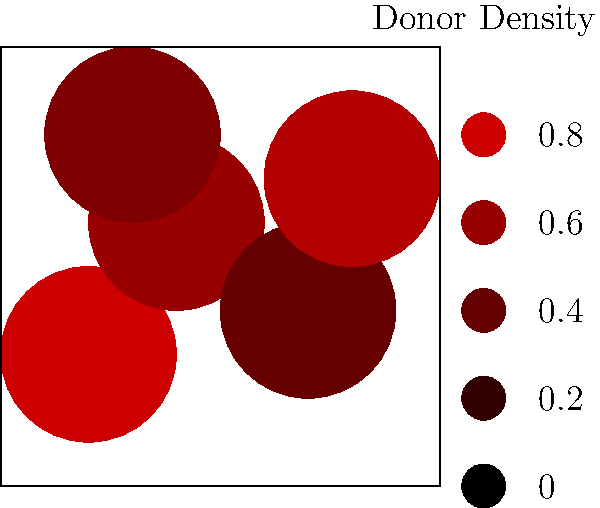Based on the heat map shown, which region of the map appears to have the highest concentration of donors, and what strategy might be most effective for engaging donors in this area? To answer this question, we need to analyze the heat map and consider fundraising strategies:

1. Analyze the heat map:
   - The map shows donor density across different regions.
   - Darker red areas indicate higher donor concentrations.
   - The darkest red area is in the upper right quadrant of the map.

2. Identify the highest concentration:
   - The upper right quadrant (northeast region) has the darkest red color.
   - This indicates the highest donor density in this area.

3. Consider effective engagement strategies:
   - For high-density donor areas, personalized approaches are often effective.
   - Hosting local events can capitalize on the concentration of donors.
   - Peer-to-peer fundraising can leverage existing donor networks.
   - Targeted direct mail or email campaigns can be cost-effective.

4. Propose a strategy:
   - Given the high concentration, a local fundraising event would be effective.
   - This allows for personal interaction with multiple donors in one setting.
   - It can also encourage donor-to-donor networking and peer influence.

5. Conclusion:
   - The northeast region has the highest donor concentration.
   - A local fundraising event would be an effective engagement strategy.
Answer: Northeast region; host a local fundraising event. 